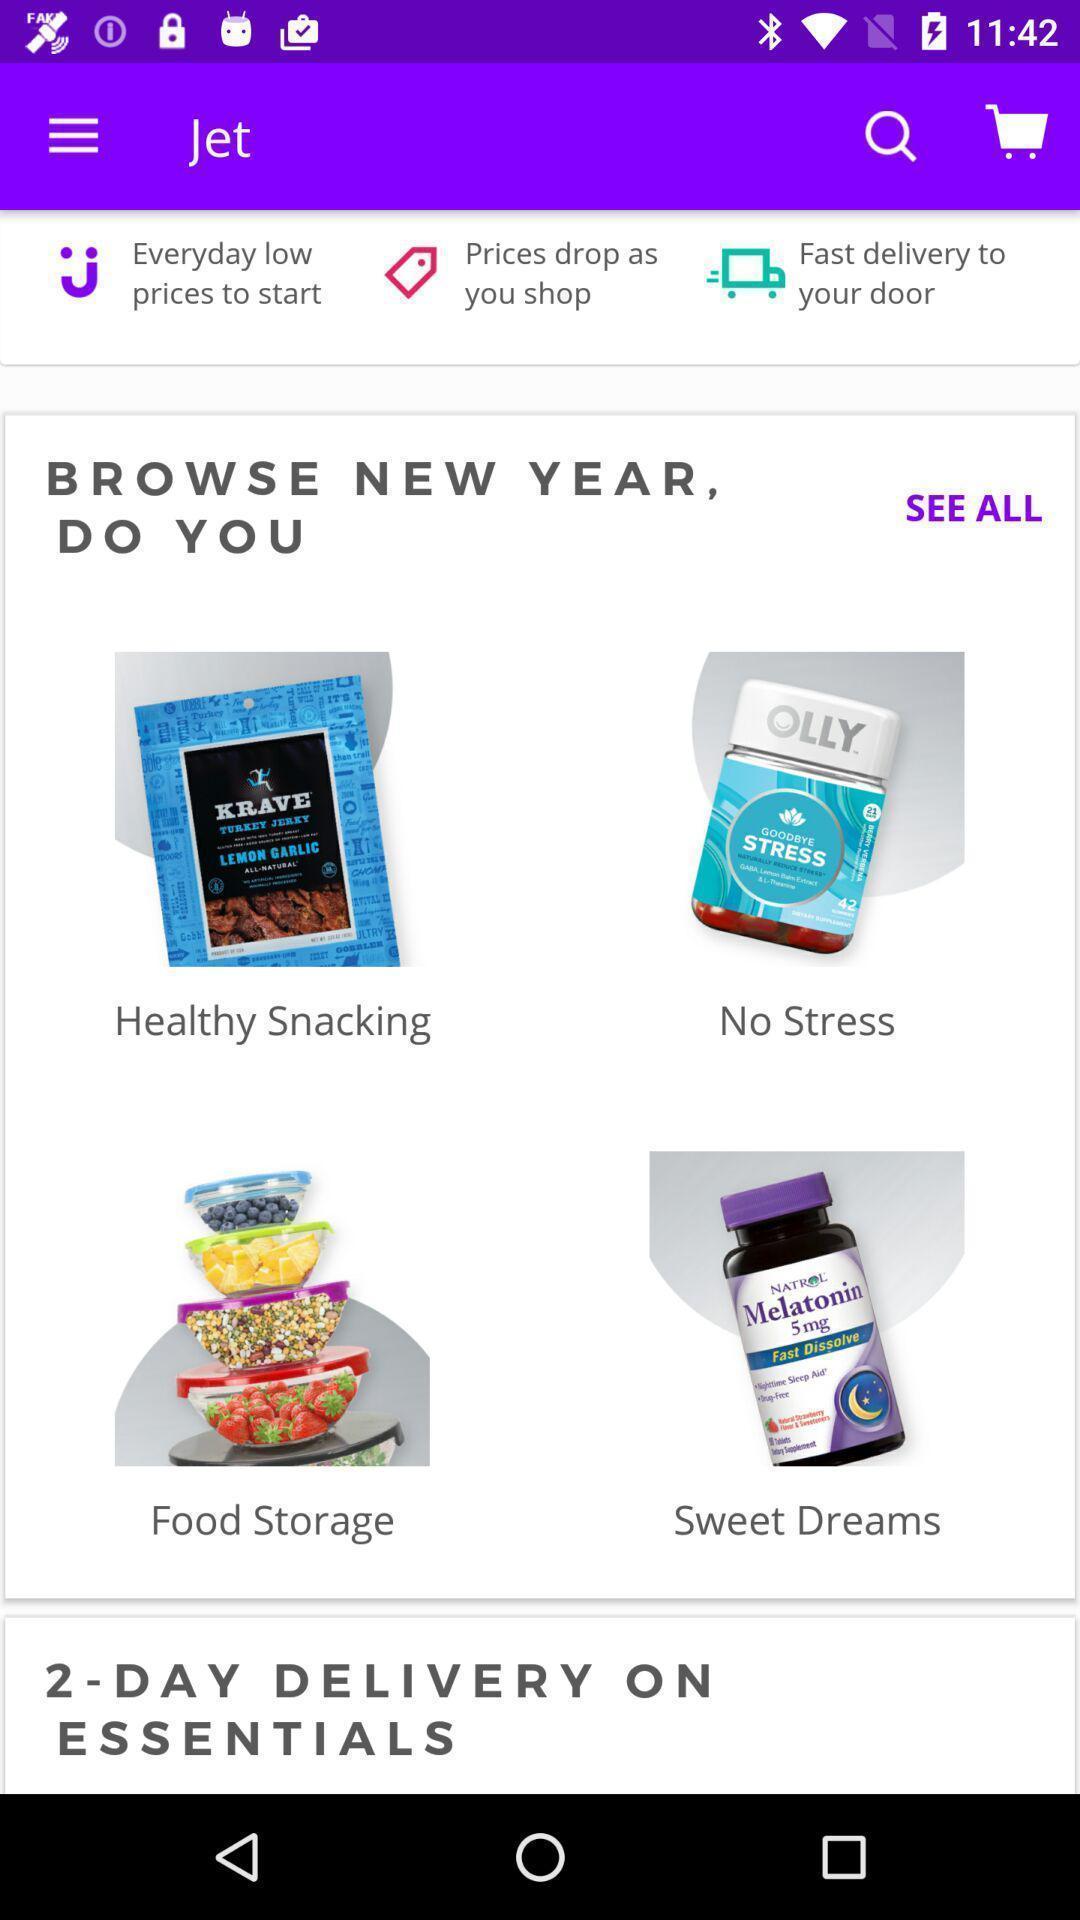Provide a description of this screenshot. Types of products in e-commerce app. 